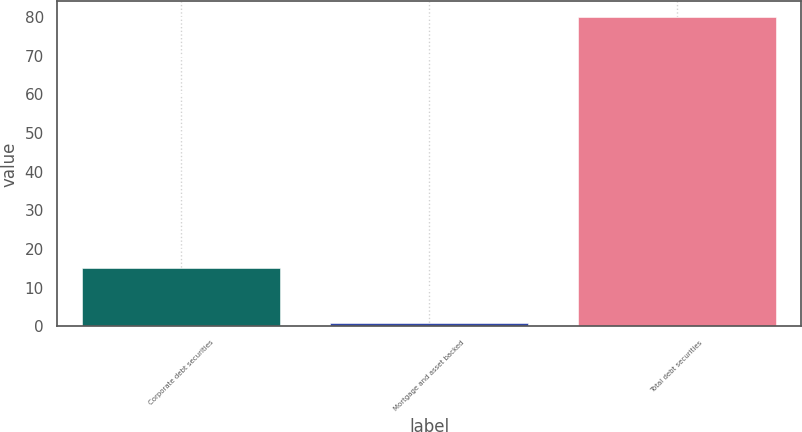<chart> <loc_0><loc_0><loc_500><loc_500><bar_chart><fcel>Corporate debt securities<fcel>Mortgage and asset backed<fcel>Total debt securities<nl><fcel>15<fcel>1<fcel>80<nl></chart> 